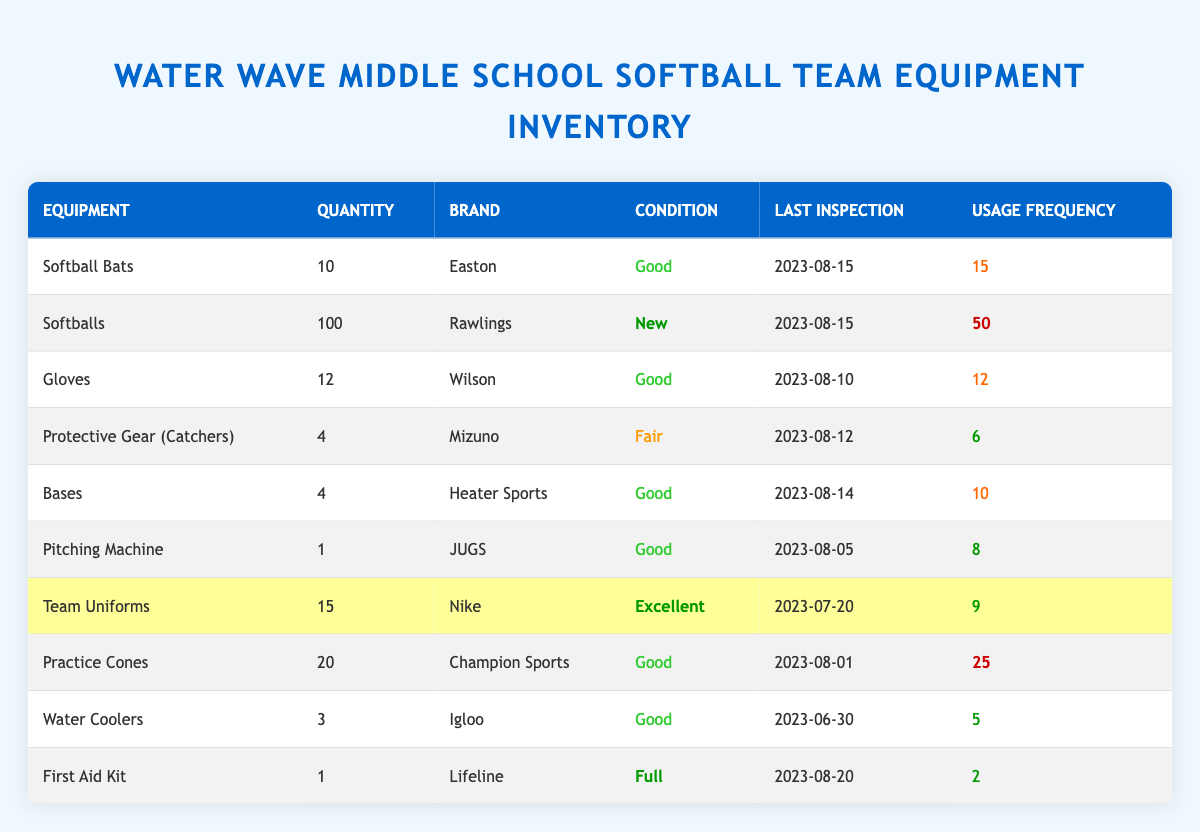What is the quantity of Softballs available? The table lists "Softballs" with a quantity of 100 in the respective row.
Answer: 100 Which equipment has the highest usage frequency? By comparing the usage frequency values in the table, "Softballs" has the highest frequency at 50.
Answer: Softballs What is the condition of the Pitching Machine? The table specifies that the condition of the "Pitching Machine" is listed as "Good."
Answer: Good How many items are labeled as in 'Excellent' condition? The table shows "Team Uniforms" and "First Aid Kit" both categorized under "Excellent" condition, making it 2 items.
Answer: 2 What is the total quantity of Practice Cones and Gloves combined? Adding the "Practice Cones" quantity of 20 and "Gloves" quantity of 12 gives us 20 + 12 = 32.
Answer: 32 Is there any equipment that has a "Fair" condition? The table indicates that "Protective Gear (Catchers)" is described as "Fair," confirming the presence of such equipment.
Answer: Yes What date was the last inspection for the Team Uniforms? The last inspection date for "Team Uniforms" is listed as "2023-07-20" in the table.
Answer: 2023-07-20 What is the average usage frequency for all equipment? To find the average, first sum the usage frequencies: 15 + 50 + 12 + 6 + 10 + 8 + 9 + 25 + 5 + 2 = 138. There are 10 items, so the average is 138 / 10 = 13.8.
Answer: 13.8 Which equipment has the lowest usage frequency? By examining the usage frequency values, "First Aid Kit" has the lowest frequency at 2.
Answer: First Aid Kit Are there any equipment items with a quantity of less than 5? The table shows "Protective Gear (Catchers)" and "Pitching Machine," where "Protective Gear" has 4 and "Pitching Machine" has 1, indicating items below 5.
Answer: Yes 